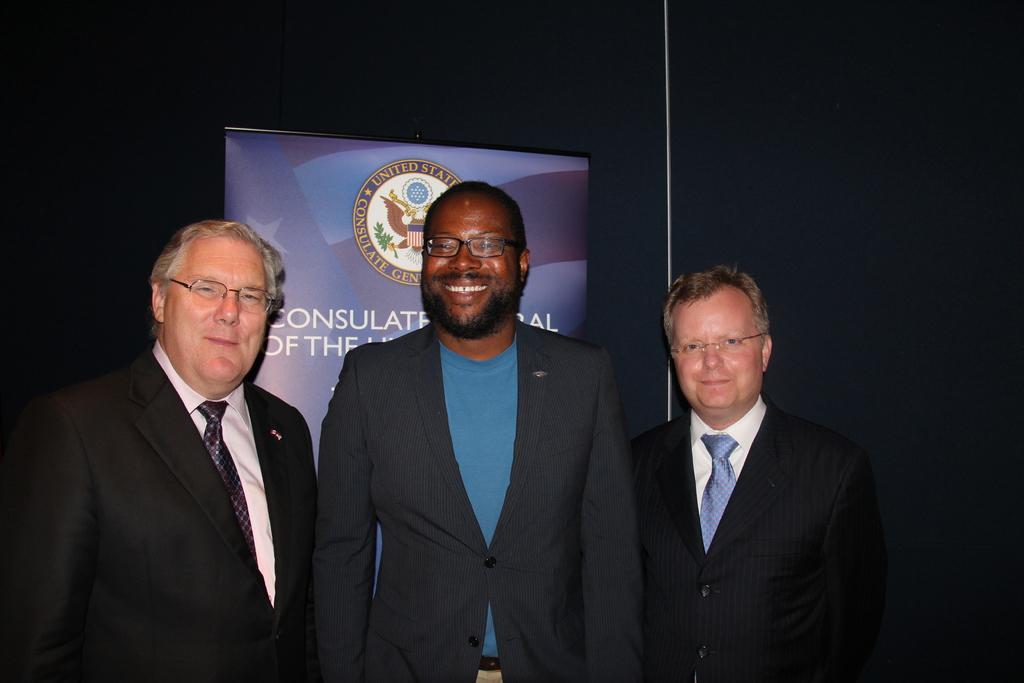Please provide a concise description of this image. In this image there are three personś, there is a banner with text on it, the background of the personś is black in color. 